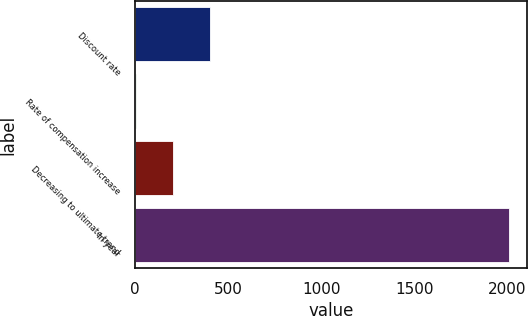Convert chart. <chart><loc_0><loc_0><loc_500><loc_500><bar_chart><fcel>Discount rate<fcel>Rate of compensation increase<fcel>Decreasing to ultimate trend<fcel>In year<nl><fcel>404.6<fcel>4<fcel>204.3<fcel>2007<nl></chart> 